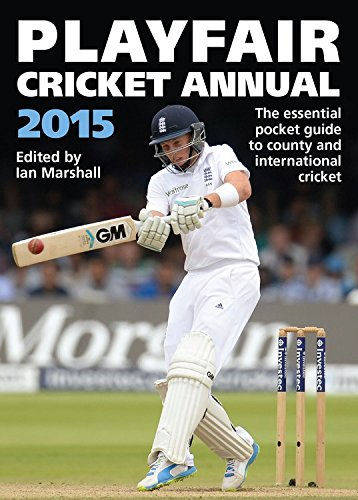What is the title of this book? The title of the book is 'Playfair Cricket Annual 2015,' a comprehensive guide covering yearly events and highlights in cricket. 